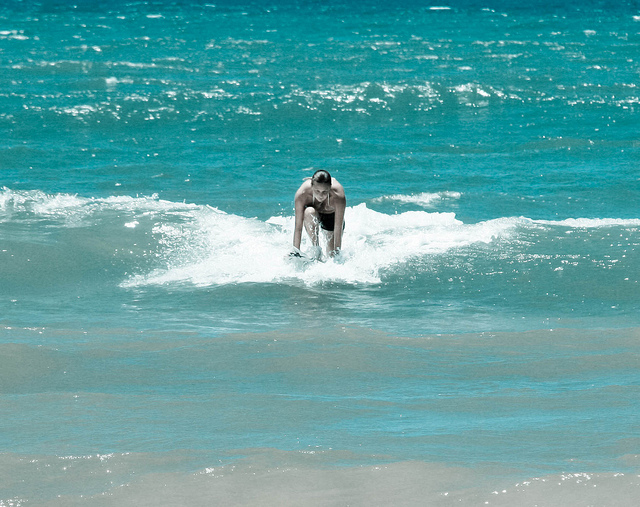<image>Will the man fall off the board? I don't know if the man will fall off the board. It could go either way. Will the man fall off the board? I don't know if the man will fall off the board. It can be both yes or no. 